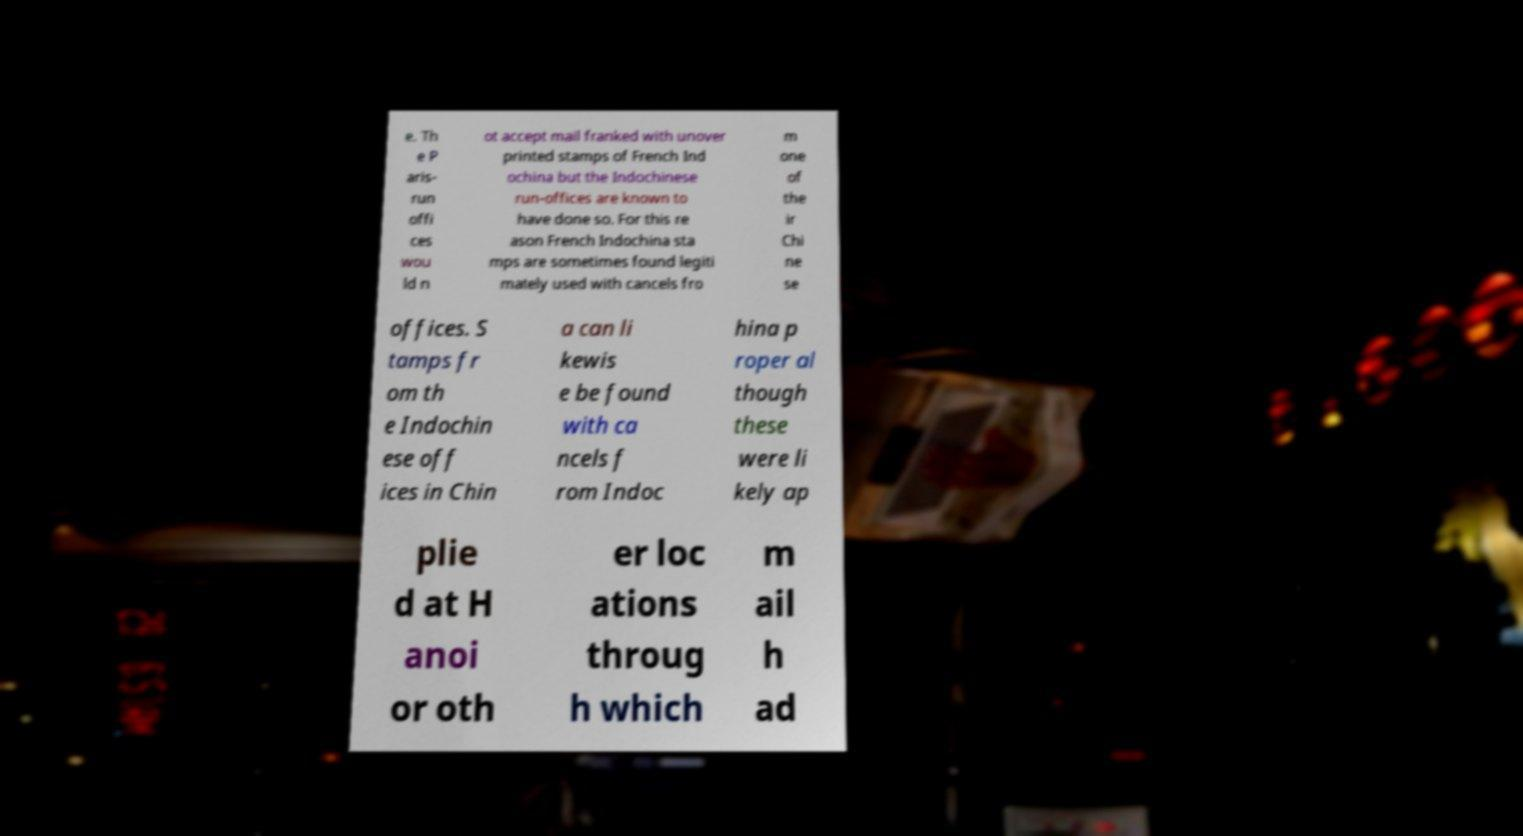Can you accurately transcribe the text from the provided image for me? e. Th e P aris- run offi ces wou ld n ot accept mail franked with unover printed stamps of French Ind ochina but the Indochinese run-offices are known to have done so. For this re ason French Indochina sta mps are sometimes found legiti mately used with cancels fro m one of the ir Chi ne se offices. S tamps fr om th e Indochin ese off ices in Chin a can li kewis e be found with ca ncels f rom Indoc hina p roper al though these were li kely ap plie d at H anoi or oth er loc ations throug h which m ail h ad 